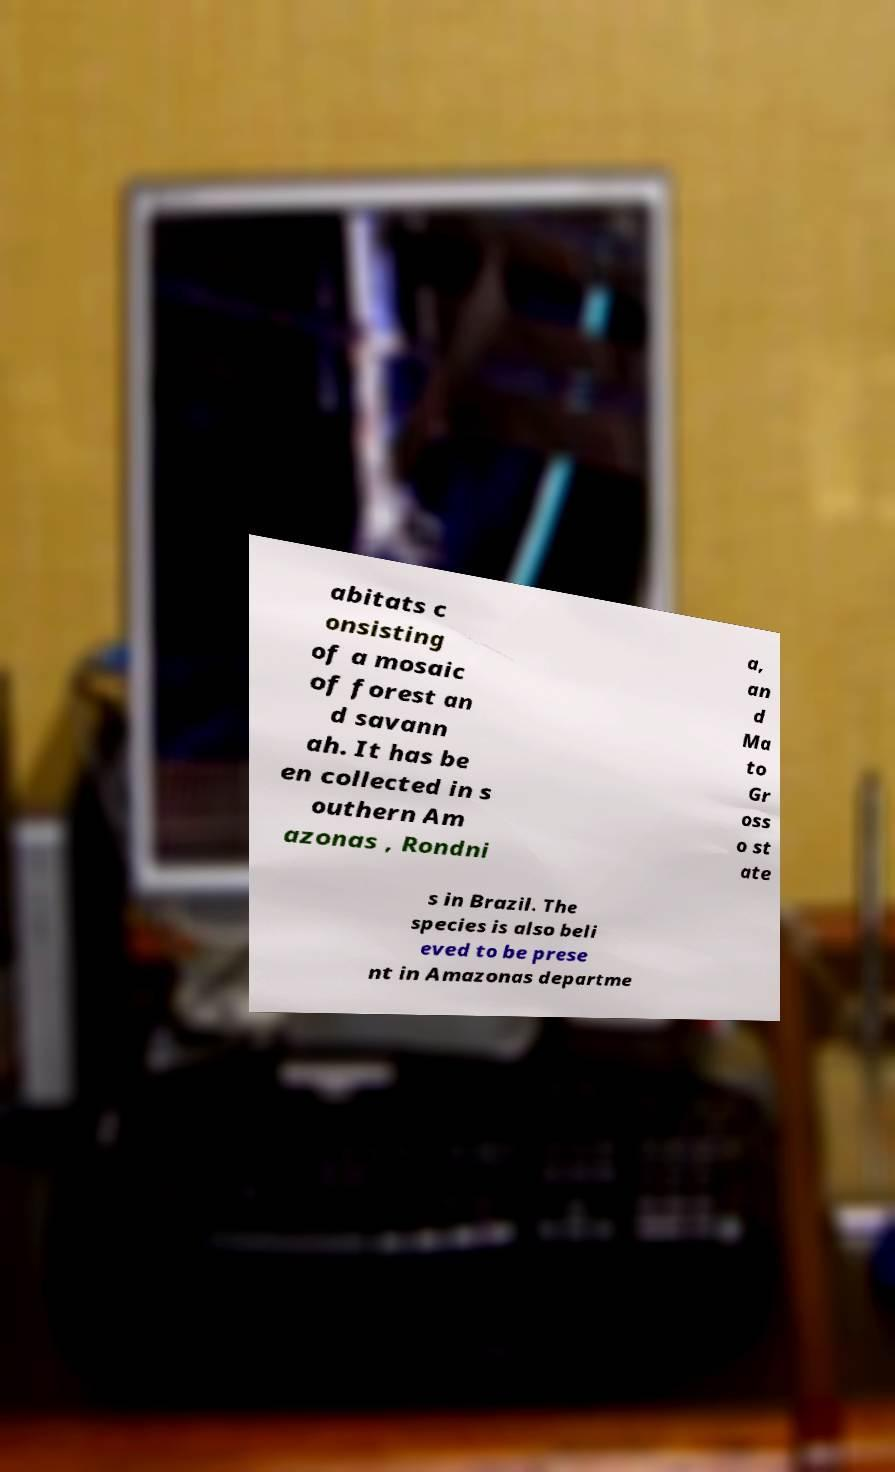Could you extract and type out the text from this image? abitats c onsisting of a mosaic of forest an d savann ah. It has be en collected in s outhern Am azonas , Rondni a, an d Ma to Gr oss o st ate s in Brazil. The species is also beli eved to be prese nt in Amazonas departme 